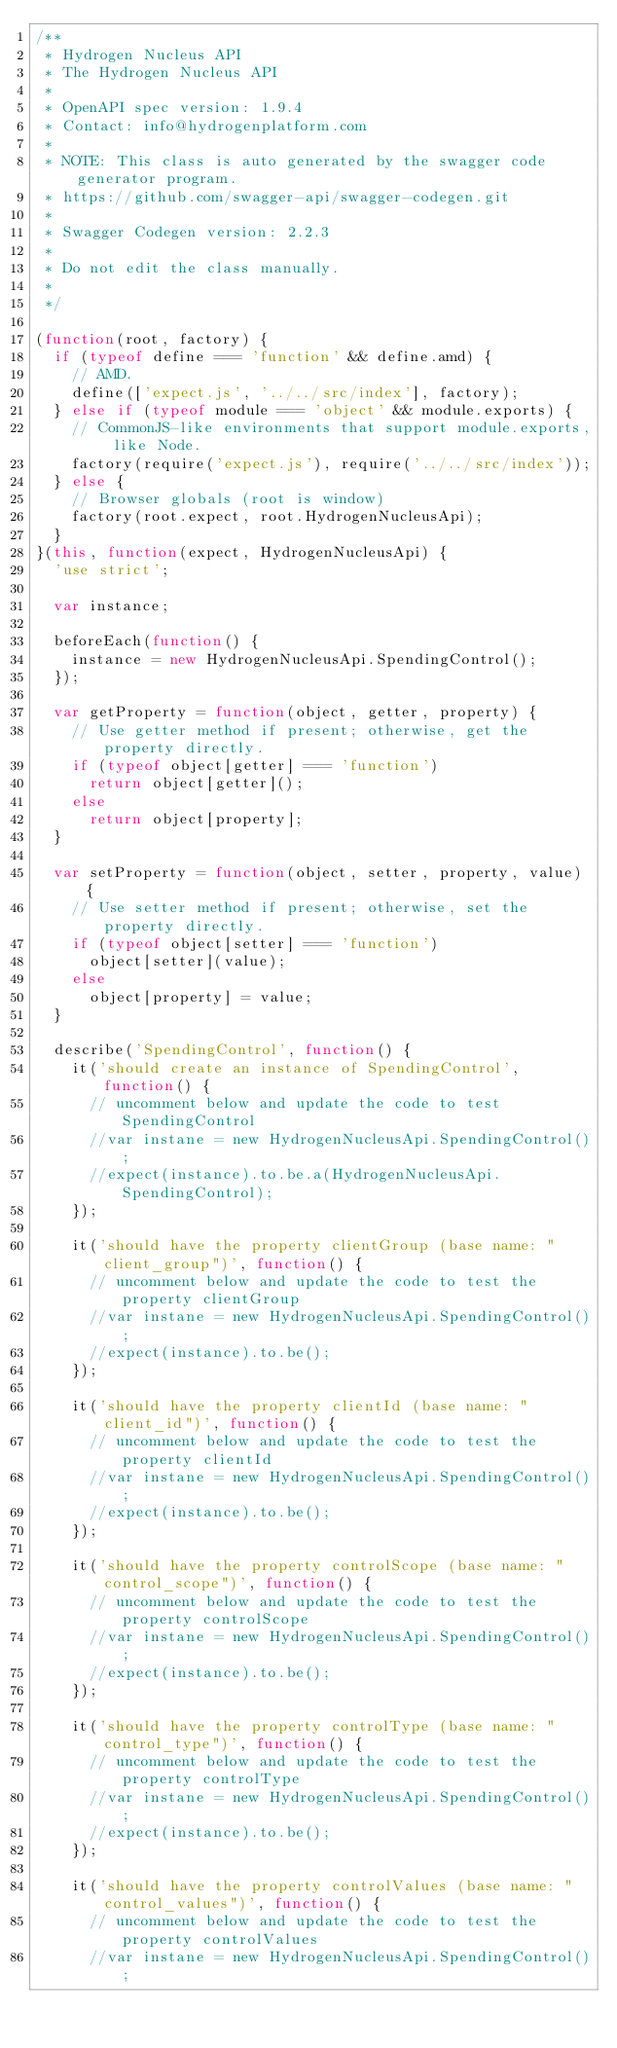<code> <loc_0><loc_0><loc_500><loc_500><_JavaScript_>/**
 * Hydrogen Nucleus API
 * The Hydrogen Nucleus API
 *
 * OpenAPI spec version: 1.9.4
 * Contact: info@hydrogenplatform.com
 *
 * NOTE: This class is auto generated by the swagger code generator program.
 * https://github.com/swagger-api/swagger-codegen.git
 *
 * Swagger Codegen version: 2.2.3
 *
 * Do not edit the class manually.
 *
 */

(function(root, factory) {
  if (typeof define === 'function' && define.amd) {
    // AMD.
    define(['expect.js', '../../src/index'], factory);
  } else if (typeof module === 'object' && module.exports) {
    // CommonJS-like environments that support module.exports, like Node.
    factory(require('expect.js'), require('../../src/index'));
  } else {
    // Browser globals (root is window)
    factory(root.expect, root.HydrogenNucleusApi);
  }
}(this, function(expect, HydrogenNucleusApi) {
  'use strict';

  var instance;

  beforeEach(function() {
    instance = new HydrogenNucleusApi.SpendingControl();
  });

  var getProperty = function(object, getter, property) {
    // Use getter method if present; otherwise, get the property directly.
    if (typeof object[getter] === 'function')
      return object[getter]();
    else
      return object[property];
  }

  var setProperty = function(object, setter, property, value) {
    // Use setter method if present; otherwise, set the property directly.
    if (typeof object[setter] === 'function')
      object[setter](value);
    else
      object[property] = value;
  }

  describe('SpendingControl', function() {
    it('should create an instance of SpendingControl', function() {
      // uncomment below and update the code to test SpendingControl
      //var instane = new HydrogenNucleusApi.SpendingControl();
      //expect(instance).to.be.a(HydrogenNucleusApi.SpendingControl);
    });

    it('should have the property clientGroup (base name: "client_group")', function() {
      // uncomment below and update the code to test the property clientGroup
      //var instane = new HydrogenNucleusApi.SpendingControl();
      //expect(instance).to.be();
    });

    it('should have the property clientId (base name: "client_id")', function() {
      // uncomment below and update the code to test the property clientId
      //var instane = new HydrogenNucleusApi.SpendingControl();
      //expect(instance).to.be();
    });

    it('should have the property controlScope (base name: "control_scope")', function() {
      // uncomment below and update the code to test the property controlScope
      //var instane = new HydrogenNucleusApi.SpendingControl();
      //expect(instance).to.be();
    });

    it('should have the property controlType (base name: "control_type")', function() {
      // uncomment below and update the code to test the property controlType
      //var instane = new HydrogenNucleusApi.SpendingControl();
      //expect(instance).to.be();
    });

    it('should have the property controlValues (base name: "control_values")', function() {
      // uncomment below and update the code to test the property controlValues
      //var instane = new HydrogenNucleusApi.SpendingControl();</code> 